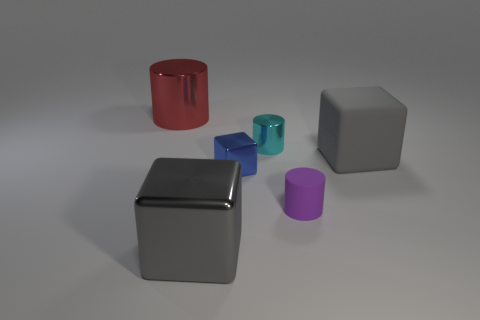How many gray blocks must be subtracted to get 1 gray blocks? 1 Subtract all metal cylinders. How many cylinders are left? 1 Subtract 1 cubes. How many cubes are left? 2 Subtract all brown blocks. Subtract all brown cylinders. How many blocks are left? 3 Subtract all red spheres. How many purple cylinders are left? 1 Subtract all small brown metal things. Subtract all small cyan metallic cylinders. How many objects are left? 5 Add 2 small purple objects. How many small purple objects are left? 3 Add 2 big red objects. How many big red objects exist? 3 Add 2 large cyan rubber cylinders. How many objects exist? 8 Subtract all cyan cylinders. How many cylinders are left? 2 